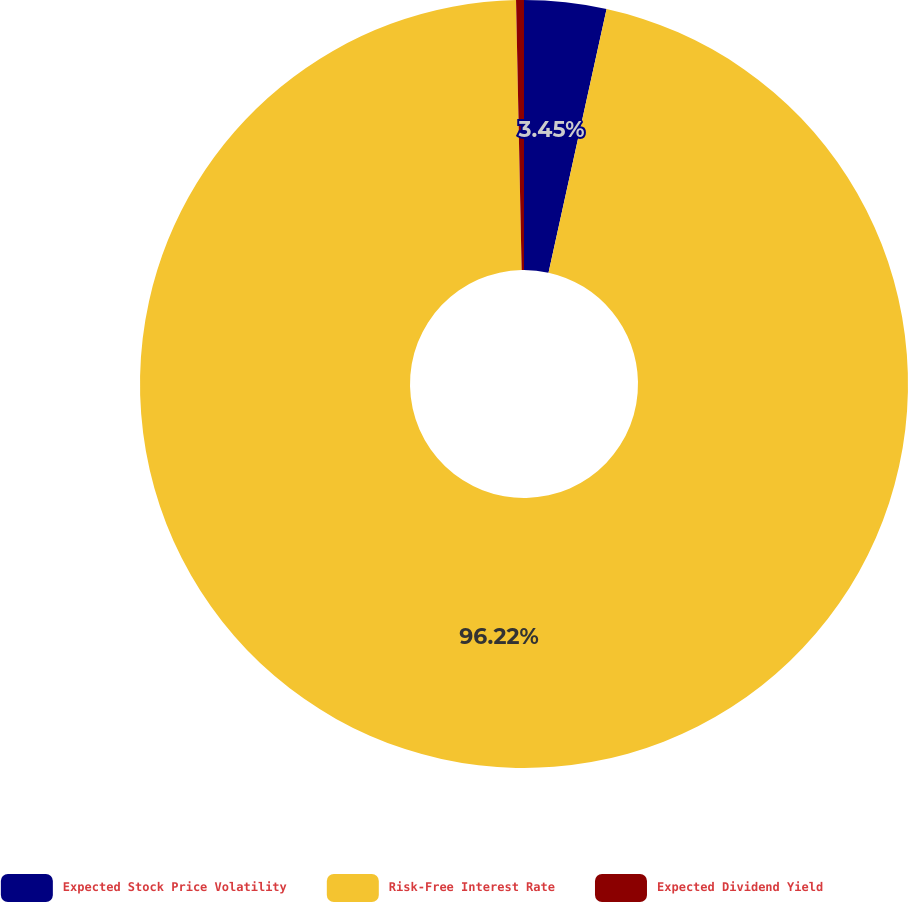<chart> <loc_0><loc_0><loc_500><loc_500><pie_chart><fcel>Expected Stock Price Volatility<fcel>Risk-Free Interest Rate<fcel>Expected Dividend Yield<nl><fcel>3.45%<fcel>96.22%<fcel>0.33%<nl></chart> 